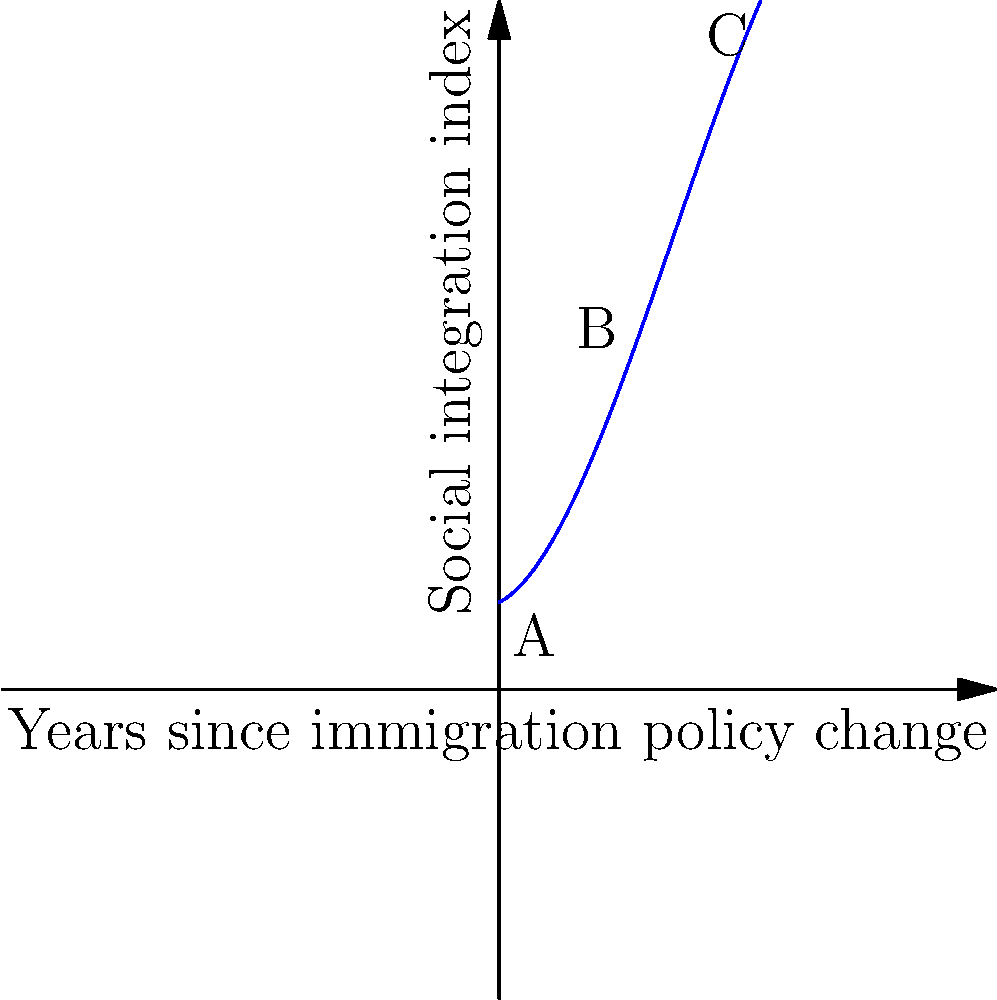The graph shows a polynomial function representing the relationship between years since a major immigration policy change (x-axis) and a social integration index (y-axis) in a specific country. Based on the graph, at which point does the rate of social integration reach its peak? To find the point where the rate of social integration reaches its peak, we need to analyze the graph:

1. The graph represents a cubic function, which has a characteristic S-shape.
2. The rate of change (slope) of the function is represented by its first derivative.
3. The peak rate occurs at the point of inflection, where the curve changes from concave up to concave down.
4. Visually, this point appears to be around the midpoint of the x-axis, near point B.
5. At point B, the curve has the steepest slope, indicating the highest rate of change.
6. Before point B, the slope is increasing (accelerating integration).
7. After point B, the slope starts decreasing (decelerating integration).
8. Point B corresponds to approximately 3 years after the immigration policy change.

Therefore, the rate of social integration reaches its peak at point B, about 3 years after the policy change.
Answer: Point B (approximately 3 years after the policy change) 